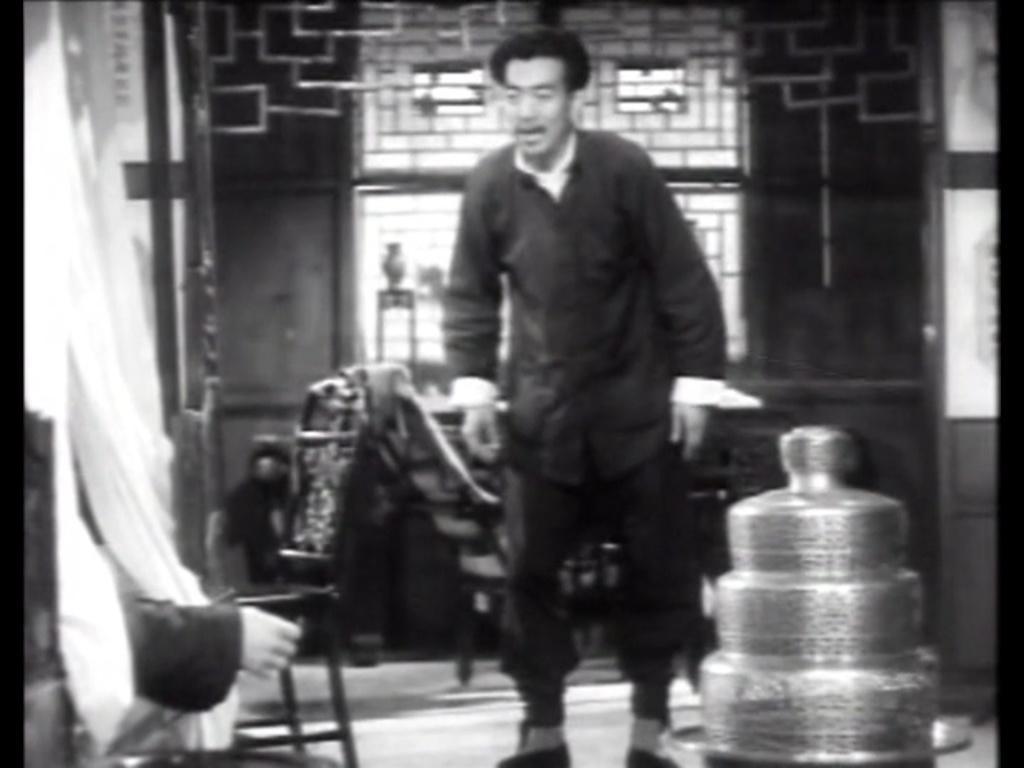Please provide a concise description of this image. This is a black and white pic. We can see a man is standing on the floor, chairs, curtains, windows, metal objects and a person's hand on the left side. In the background the image is not clear but we can see a person and on the right side there is an object. 